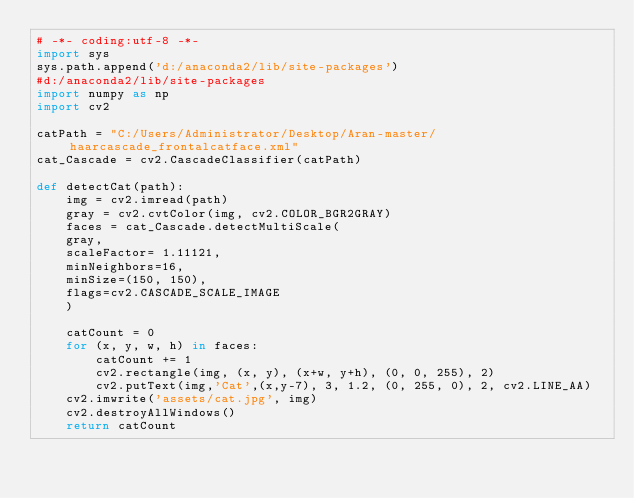Convert code to text. <code><loc_0><loc_0><loc_500><loc_500><_Python_># -*- coding:utf-8 -*-
import sys
sys.path.append('d:/anaconda2/lib/site-packages')
#d:/anaconda2/lib/site-packages
import numpy as np
import cv2

catPath = "C:/Users/Administrator/Desktop/Aran-master/haarcascade_frontalcatface.xml"
cat_Cascade = cv2.CascadeClassifier(catPath)

def detectCat(path):
    img = cv2.imread(path)
    gray = cv2.cvtColor(img, cv2.COLOR_BGR2GRAY)
    faces = cat_Cascade.detectMultiScale(
    gray,
    scaleFactor= 1.11121,
    minNeighbors=16,
    minSize=(150, 150),
    flags=cv2.CASCADE_SCALE_IMAGE
    )   

    catCount = 0
    for (x, y, w, h) in faces:
        catCount += 1
        cv2.rectangle(img, (x, y), (x+w, y+h), (0, 0, 255), 2)
        cv2.putText(img,'Cat',(x,y-7), 3, 1.2, (0, 255, 0), 2, cv2.LINE_AA)
    cv2.imwrite('assets/cat.jpg', img)
    cv2.destroyAllWindows()
    return catCount</code> 